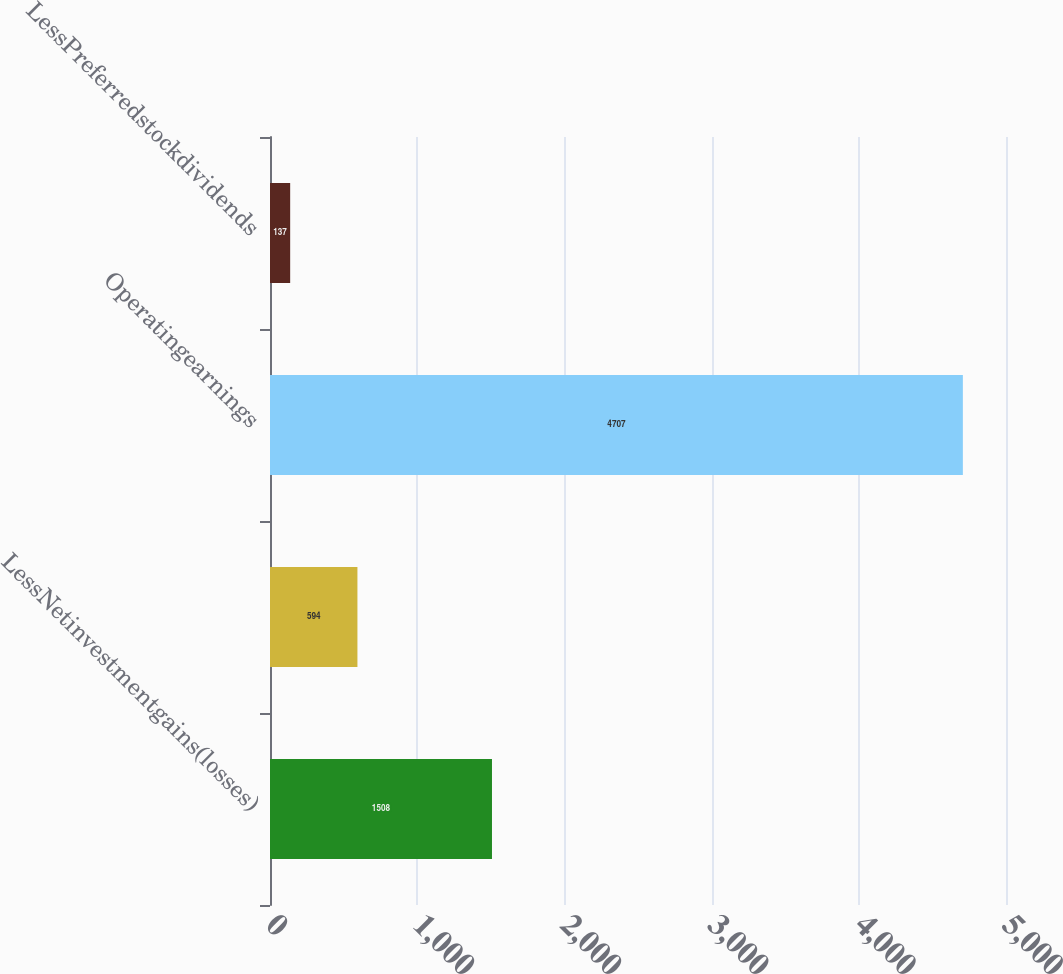<chart> <loc_0><loc_0><loc_500><loc_500><bar_chart><fcel>LessNetinvestmentgains(losses)<fcel>Unnamed: 1<fcel>Operatingearnings<fcel>LessPreferredstockdividends<nl><fcel>1508<fcel>594<fcel>4707<fcel>137<nl></chart> 